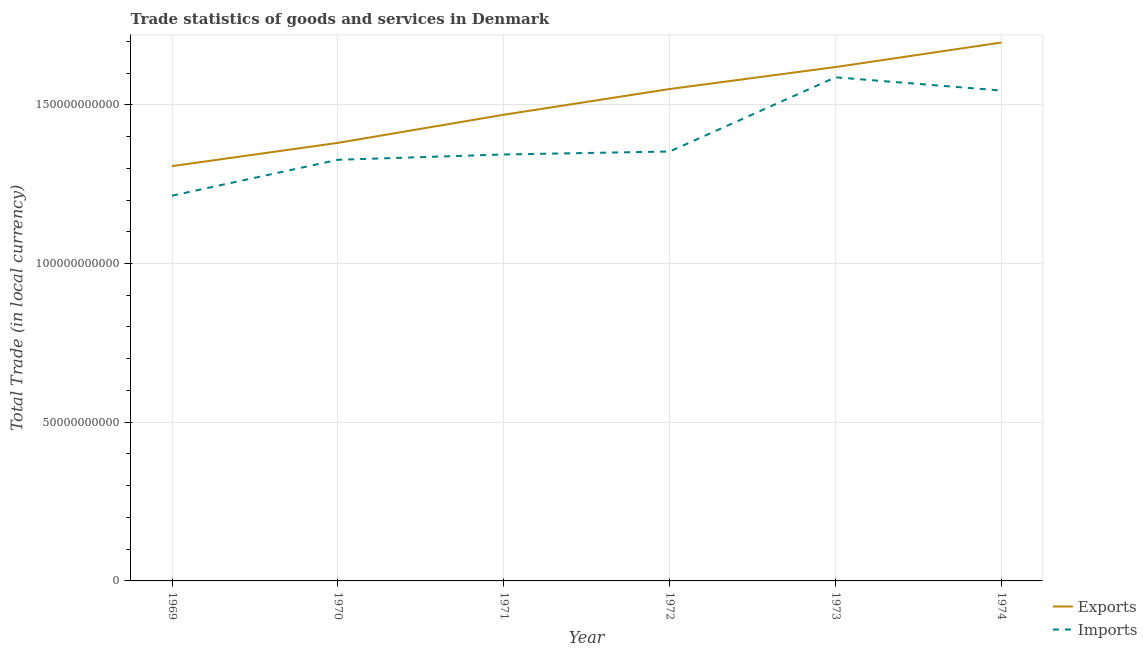Does the line corresponding to imports of goods and services intersect with the line corresponding to export of goods and services?
Offer a very short reply. No. What is the export of goods and services in 1971?
Give a very brief answer. 1.47e+11. Across all years, what is the maximum imports of goods and services?
Provide a short and direct response. 1.59e+11. Across all years, what is the minimum imports of goods and services?
Your answer should be very brief. 1.21e+11. In which year was the imports of goods and services minimum?
Offer a terse response. 1969. What is the total imports of goods and services in the graph?
Offer a terse response. 8.37e+11. What is the difference between the imports of goods and services in 1969 and that in 1972?
Ensure brevity in your answer.  -1.39e+1. What is the difference between the export of goods and services in 1974 and the imports of goods and services in 1969?
Your response must be concise. 4.83e+1. What is the average imports of goods and services per year?
Your answer should be compact. 1.39e+11. In the year 1974, what is the difference between the export of goods and services and imports of goods and services?
Ensure brevity in your answer.  1.51e+1. What is the ratio of the imports of goods and services in 1969 to that in 1971?
Your answer should be very brief. 0.9. What is the difference between the highest and the second highest export of goods and services?
Offer a terse response. 7.72e+09. What is the difference between the highest and the lowest imports of goods and services?
Offer a very short reply. 3.73e+1. In how many years, is the export of goods and services greater than the average export of goods and services taken over all years?
Keep it short and to the point. 3. How many lines are there?
Keep it short and to the point. 2. What is the difference between two consecutive major ticks on the Y-axis?
Your response must be concise. 5.00e+1. Are the values on the major ticks of Y-axis written in scientific E-notation?
Give a very brief answer. No. Does the graph contain grids?
Make the answer very short. Yes. Where does the legend appear in the graph?
Offer a terse response. Bottom right. How many legend labels are there?
Keep it short and to the point. 2. How are the legend labels stacked?
Keep it short and to the point. Vertical. What is the title of the graph?
Offer a very short reply. Trade statistics of goods and services in Denmark. Does "Nitrous oxide emissions" appear as one of the legend labels in the graph?
Offer a terse response. No. What is the label or title of the X-axis?
Keep it short and to the point. Year. What is the label or title of the Y-axis?
Keep it short and to the point. Total Trade (in local currency). What is the Total Trade (in local currency) of Exports in 1969?
Your answer should be compact. 1.31e+11. What is the Total Trade (in local currency) in Imports in 1969?
Your answer should be compact. 1.21e+11. What is the Total Trade (in local currency) of Exports in 1970?
Provide a succinct answer. 1.38e+11. What is the Total Trade (in local currency) in Imports in 1970?
Provide a short and direct response. 1.33e+11. What is the Total Trade (in local currency) of Exports in 1971?
Provide a short and direct response. 1.47e+11. What is the Total Trade (in local currency) of Imports in 1971?
Ensure brevity in your answer.  1.34e+11. What is the Total Trade (in local currency) in Exports in 1972?
Provide a short and direct response. 1.55e+11. What is the Total Trade (in local currency) in Imports in 1972?
Offer a terse response. 1.35e+11. What is the Total Trade (in local currency) in Exports in 1973?
Provide a succinct answer. 1.62e+11. What is the Total Trade (in local currency) in Imports in 1973?
Provide a succinct answer. 1.59e+11. What is the Total Trade (in local currency) in Exports in 1974?
Keep it short and to the point. 1.70e+11. What is the Total Trade (in local currency) in Imports in 1974?
Give a very brief answer. 1.54e+11. Across all years, what is the maximum Total Trade (in local currency) in Exports?
Ensure brevity in your answer.  1.70e+11. Across all years, what is the maximum Total Trade (in local currency) in Imports?
Your response must be concise. 1.59e+11. Across all years, what is the minimum Total Trade (in local currency) in Exports?
Provide a short and direct response. 1.31e+11. Across all years, what is the minimum Total Trade (in local currency) of Imports?
Ensure brevity in your answer.  1.21e+11. What is the total Total Trade (in local currency) of Exports in the graph?
Your answer should be very brief. 9.02e+11. What is the total Total Trade (in local currency) in Imports in the graph?
Make the answer very short. 8.37e+11. What is the difference between the Total Trade (in local currency) of Exports in 1969 and that in 1970?
Your answer should be very brief. -7.32e+09. What is the difference between the Total Trade (in local currency) in Imports in 1969 and that in 1970?
Ensure brevity in your answer.  -1.13e+1. What is the difference between the Total Trade (in local currency) of Exports in 1969 and that in 1971?
Keep it short and to the point. -1.62e+1. What is the difference between the Total Trade (in local currency) in Imports in 1969 and that in 1971?
Provide a short and direct response. -1.30e+1. What is the difference between the Total Trade (in local currency) of Exports in 1969 and that in 1972?
Provide a succinct answer. -2.43e+1. What is the difference between the Total Trade (in local currency) in Imports in 1969 and that in 1972?
Offer a very short reply. -1.39e+1. What is the difference between the Total Trade (in local currency) of Exports in 1969 and that in 1973?
Provide a short and direct response. -3.12e+1. What is the difference between the Total Trade (in local currency) in Imports in 1969 and that in 1973?
Your response must be concise. -3.73e+1. What is the difference between the Total Trade (in local currency) in Exports in 1969 and that in 1974?
Offer a terse response. -3.89e+1. What is the difference between the Total Trade (in local currency) of Imports in 1969 and that in 1974?
Offer a very short reply. -3.31e+1. What is the difference between the Total Trade (in local currency) of Exports in 1970 and that in 1971?
Provide a short and direct response. -8.86e+09. What is the difference between the Total Trade (in local currency) in Imports in 1970 and that in 1971?
Offer a terse response. -1.68e+09. What is the difference between the Total Trade (in local currency) in Exports in 1970 and that in 1972?
Ensure brevity in your answer.  -1.70e+1. What is the difference between the Total Trade (in local currency) of Imports in 1970 and that in 1972?
Give a very brief answer. -2.61e+09. What is the difference between the Total Trade (in local currency) in Exports in 1970 and that in 1973?
Provide a succinct answer. -2.39e+1. What is the difference between the Total Trade (in local currency) of Imports in 1970 and that in 1973?
Provide a succinct answer. -2.60e+1. What is the difference between the Total Trade (in local currency) of Exports in 1970 and that in 1974?
Your response must be concise. -3.16e+1. What is the difference between the Total Trade (in local currency) of Imports in 1970 and that in 1974?
Ensure brevity in your answer.  -2.18e+1. What is the difference between the Total Trade (in local currency) of Exports in 1971 and that in 1972?
Offer a terse response. -8.10e+09. What is the difference between the Total Trade (in local currency) of Imports in 1971 and that in 1972?
Give a very brief answer. -9.33e+08. What is the difference between the Total Trade (in local currency) of Exports in 1971 and that in 1973?
Give a very brief answer. -1.50e+1. What is the difference between the Total Trade (in local currency) in Imports in 1971 and that in 1973?
Your response must be concise. -2.43e+1. What is the difference between the Total Trade (in local currency) in Exports in 1971 and that in 1974?
Your response must be concise. -2.27e+1. What is the difference between the Total Trade (in local currency) of Imports in 1971 and that in 1974?
Ensure brevity in your answer.  -2.01e+1. What is the difference between the Total Trade (in local currency) of Exports in 1972 and that in 1973?
Provide a short and direct response. -6.93e+09. What is the difference between the Total Trade (in local currency) of Imports in 1972 and that in 1973?
Keep it short and to the point. -2.34e+1. What is the difference between the Total Trade (in local currency) in Exports in 1972 and that in 1974?
Provide a succinct answer. -1.46e+1. What is the difference between the Total Trade (in local currency) of Imports in 1972 and that in 1974?
Offer a terse response. -1.92e+1. What is the difference between the Total Trade (in local currency) in Exports in 1973 and that in 1974?
Make the answer very short. -7.72e+09. What is the difference between the Total Trade (in local currency) of Imports in 1973 and that in 1974?
Your response must be concise. 4.17e+09. What is the difference between the Total Trade (in local currency) in Exports in 1969 and the Total Trade (in local currency) in Imports in 1970?
Your answer should be very brief. -1.99e+09. What is the difference between the Total Trade (in local currency) in Exports in 1969 and the Total Trade (in local currency) in Imports in 1971?
Keep it short and to the point. -3.67e+09. What is the difference between the Total Trade (in local currency) in Exports in 1969 and the Total Trade (in local currency) in Imports in 1972?
Offer a very short reply. -4.60e+09. What is the difference between the Total Trade (in local currency) of Exports in 1969 and the Total Trade (in local currency) of Imports in 1973?
Provide a short and direct response. -2.80e+1. What is the difference between the Total Trade (in local currency) in Exports in 1969 and the Total Trade (in local currency) in Imports in 1974?
Your answer should be compact. -2.38e+1. What is the difference between the Total Trade (in local currency) in Exports in 1970 and the Total Trade (in local currency) in Imports in 1971?
Provide a succinct answer. 3.66e+09. What is the difference between the Total Trade (in local currency) in Exports in 1970 and the Total Trade (in local currency) in Imports in 1972?
Ensure brevity in your answer.  2.72e+09. What is the difference between the Total Trade (in local currency) of Exports in 1970 and the Total Trade (in local currency) of Imports in 1973?
Make the answer very short. -2.07e+1. What is the difference between the Total Trade (in local currency) in Exports in 1970 and the Total Trade (in local currency) in Imports in 1974?
Give a very brief answer. -1.65e+1. What is the difference between the Total Trade (in local currency) in Exports in 1971 and the Total Trade (in local currency) in Imports in 1972?
Provide a short and direct response. 1.16e+1. What is the difference between the Total Trade (in local currency) of Exports in 1971 and the Total Trade (in local currency) of Imports in 1973?
Provide a succinct answer. -1.18e+1. What is the difference between the Total Trade (in local currency) in Exports in 1971 and the Total Trade (in local currency) in Imports in 1974?
Your response must be concise. -7.62e+09. What is the difference between the Total Trade (in local currency) in Exports in 1972 and the Total Trade (in local currency) in Imports in 1973?
Ensure brevity in your answer.  -3.69e+09. What is the difference between the Total Trade (in local currency) of Exports in 1972 and the Total Trade (in local currency) of Imports in 1974?
Provide a short and direct response. 4.81e+08. What is the difference between the Total Trade (in local currency) of Exports in 1973 and the Total Trade (in local currency) of Imports in 1974?
Provide a short and direct response. 7.41e+09. What is the average Total Trade (in local currency) in Exports per year?
Provide a short and direct response. 1.50e+11. What is the average Total Trade (in local currency) of Imports per year?
Offer a very short reply. 1.39e+11. In the year 1969, what is the difference between the Total Trade (in local currency) of Exports and Total Trade (in local currency) of Imports?
Your answer should be very brief. 9.32e+09. In the year 1970, what is the difference between the Total Trade (in local currency) in Exports and Total Trade (in local currency) in Imports?
Provide a succinct answer. 5.33e+09. In the year 1971, what is the difference between the Total Trade (in local currency) of Exports and Total Trade (in local currency) of Imports?
Your answer should be very brief. 1.25e+1. In the year 1972, what is the difference between the Total Trade (in local currency) in Exports and Total Trade (in local currency) in Imports?
Offer a terse response. 1.97e+1. In the year 1973, what is the difference between the Total Trade (in local currency) in Exports and Total Trade (in local currency) in Imports?
Make the answer very short. 3.23e+09. In the year 1974, what is the difference between the Total Trade (in local currency) in Exports and Total Trade (in local currency) in Imports?
Offer a very short reply. 1.51e+1. What is the ratio of the Total Trade (in local currency) in Exports in 1969 to that in 1970?
Provide a short and direct response. 0.95. What is the ratio of the Total Trade (in local currency) in Imports in 1969 to that in 1970?
Your response must be concise. 0.91. What is the ratio of the Total Trade (in local currency) of Exports in 1969 to that in 1971?
Provide a short and direct response. 0.89. What is the ratio of the Total Trade (in local currency) of Imports in 1969 to that in 1971?
Offer a very short reply. 0.9. What is the ratio of the Total Trade (in local currency) of Exports in 1969 to that in 1972?
Your response must be concise. 0.84. What is the ratio of the Total Trade (in local currency) in Imports in 1969 to that in 1972?
Your response must be concise. 0.9. What is the ratio of the Total Trade (in local currency) of Exports in 1969 to that in 1973?
Ensure brevity in your answer.  0.81. What is the ratio of the Total Trade (in local currency) of Imports in 1969 to that in 1973?
Your response must be concise. 0.76. What is the ratio of the Total Trade (in local currency) of Exports in 1969 to that in 1974?
Offer a terse response. 0.77. What is the ratio of the Total Trade (in local currency) in Imports in 1969 to that in 1974?
Keep it short and to the point. 0.79. What is the ratio of the Total Trade (in local currency) in Exports in 1970 to that in 1971?
Offer a terse response. 0.94. What is the ratio of the Total Trade (in local currency) in Imports in 1970 to that in 1971?
Make the answer very short. 0.99. What is the ratio of the Total Trade (in local currency) in Exports in 1970 to that in 1972?
Your answer should be compact. 0.89. What is the ratio of the Total Trade (in local currency) of Imports in 1970 to that in 1972?
Give a very brief answer. 0.98. What is the ratio of the Total Trade (in local currency) of Exports in 1970 to that in 1973?
Offer a terse response. 0.85. What is the ratio of the Total Trade (in local currency) in Imports in 1970 to that in 1973?
Offer a terse response. 0.84. What is the ratio of the Total Trade (in local currency) of Exports in 1970 to that in 1974?
Make the answer very short. 0.81. What is the ratio of the Total Trade (in local currency) of Imports in 1970 to that in 1974?
Offer a terse response. 0.86. What is the ratio of the Total Trade (in local currency) of Exports in 1971 to that in 1972?
Offer a very short reply. 0.95. What is the ratio of the Total Trade (in local currency) of Imports in 1971 to that in 1972?
Your answer should be very brief. 0.99. What is the ratio of the Total Trade (in local currency) of Exports in 1971 to that in 1973?
Offer a very short reply. 0.91. What is the ratio of the Total Trade (in local currency) of Imports in 1971 to that in 1973?
Make the answer very short. 0.85. What is the ratio of the Total Trade (in local currency) of Exports in 1971 to that in 1974?
Your response must be concise. 0.87. What is the ratio of the Total Trade (in local currency) in Imports in 1971 to that in 1974?
Ensure brevity in your answer.  0.87. What is the ratio of the Total Trade (in local currency) of Exports in 1972 to that in 1973?
Keep it short and to the point. 0.96. What is the ratio of the Total Trade (in local currency) of Imports in 1972 to that in 1973?
Your response must be concise. 0.85. What is the ratio of the Total Trade (in local currency) of Exports in 1972 to that in 1974?
Make the answer very short. 0.91. What is the ratio of the Total Trade (in local currency) in Imports in 1972 to that in 1974?
Provide a short and direct response. 0.88. What is the ratio of the Total Trade (in local currency) in Exports in 1973 to that in 1974?
Offer a terse response. 0.95. What is the difference between the highest and the second highest Total Trade (in local currency) of Exports?
Keep it short and to the point. 7.72e+09. What is the difference between the highest and the second highest Total Trade (in local currency) in Imports?
Keep it short and to the point. 4.17e+09. What is the difference between the highest and the lowest Total Trade (in local currency) of Exports?
Your response must be concise. 3.89e+1. What is the difference between the highest and the lowest Total Trade (in local currency) in Imports?
Your answer should be compact. 3.73e+1. 